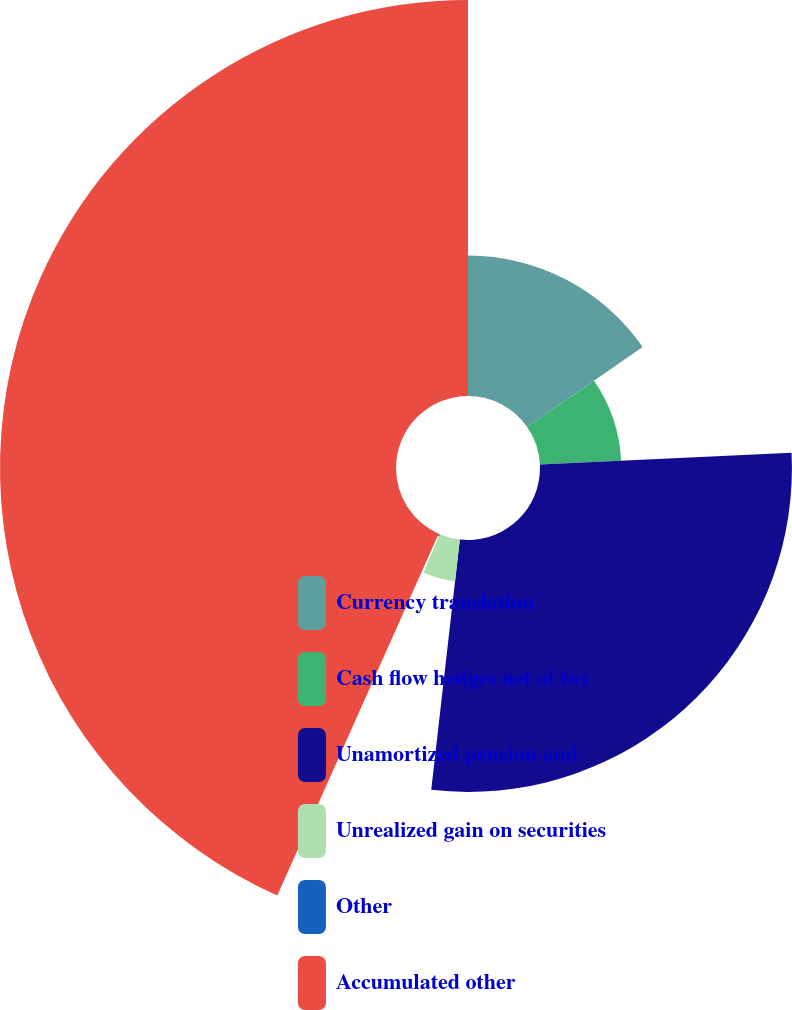Convert chart. <chart><loc_0><loc_0><loc_500><loc_500><pie_chart><fcel>Currency translation<fcel>Cash flow hedges net of tax<fcel>Unamortized pension and<fcel>Unrealized gain on securities<fcel>Other<fcel>Accumulated other<nl><fcel>15.36%<fcel>8.89%<fcel>27.56%<fcel>4.59%<fcel>0.28%<fcel>43.32%<nl></chart> 